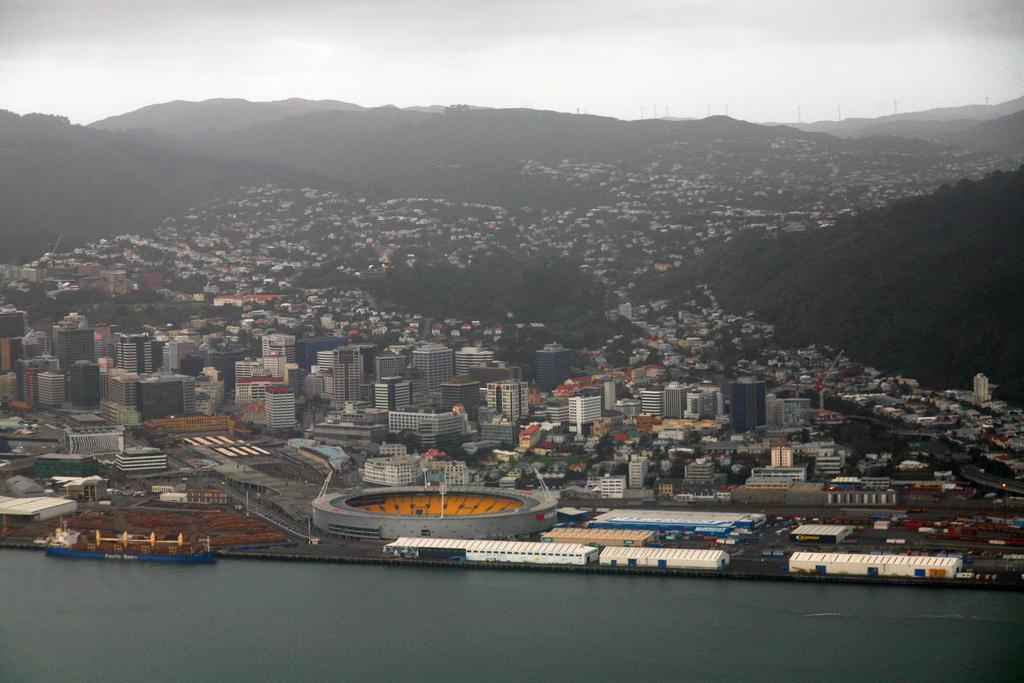What is the main subject of the image? The main subject of the image is a boat. Where is the boat located? The boat is on water. What can be seen beside the water? There are buildings, trees, and other objects beside the water. What is visible in the background of the image? Mountains and the sky are visible in the background. How many cakes are being used as decorations on the boat in the image? There are no cakes present in the image; the boat is on water with no visible decorations. 